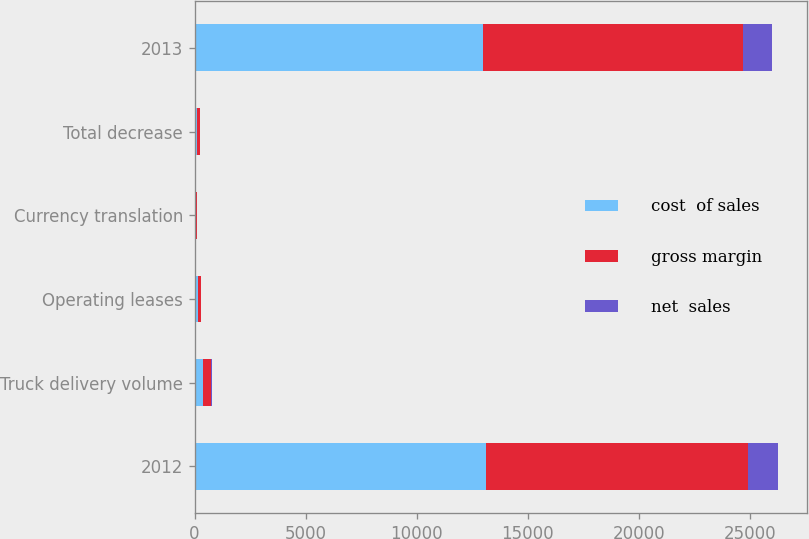Convert chart to OTSL. <chart><loc_0><loc_0><loc_500><loc_500><stacked_bar_chart><ecel><fcel>2012<fcel>Truck delivery volume<fcel>Operating leases<fcel>Currency translation<fcel>Total decrease<fcel>2013<nl><fcel>cost  of sales<fcel>13131.5<fcel>399.7<fcel>149<fcel>64.5<fcel>128.6<fcel>13002.9<nl><fcel>gross margin<fcel>11794<fcel>324.5<fcel>142.4<fcel>57.2<fcel>102.1<fcel>11691.9<nl><fcel>net  sales<fcel>1337.5<fcel>75.2<fcel>6.6<fcel>7.3<fcel>26.5<fcel>1311<nl></chart> 